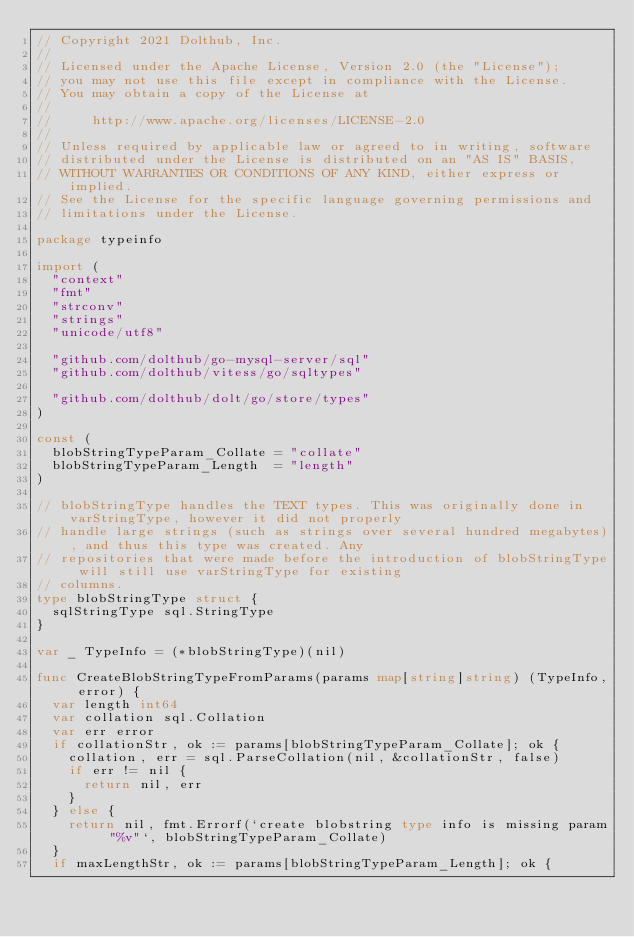<code> <loc_0><loc_0><loc_500><loc_500><_Go_>// Copyright 2021 Dolthub, Inc.
//
// Licensed under the Apache License, Version 2.0 (the "License");
// you may not use this file except in compliance with the License.
// You may obtain a copy of the License at
//
//     http://www.apache.org/licenses/LICENSE-2.0
//
// Unless required by applicable law or agreed to in writing, software
// distributed under the License is distributed on an "AS IS" BASIS,
// WITHOUT WARRANTIES OR CONDITIONS OF ANY KIND, either express or implied.
// See the License for the specific language governing permissions and
// limitations under the License.

package typeinfo

import (
	"context"
	"fmt"
	"strconv"
	"strings"
	"unicode/utf8"

	"github.com/dolthub/go-mysql-server/sql"
	"github.com/dolthub/vitess/go/sqltypes"

	"github.com/dolthub/dolt/go/store/types"
)

const (
	blobStringTypeParam_Collate = "collate"
	blobStringTypeParam_Length  = "length"
)

// blobStringType handles the TEXT types. This was originally done in varStringType, however it did not properly
// handle large strings (such as strings over several hundred megabytes), and thus this type was created. Any
// repositories that were made before the introduction of blobStringType will still use varStringType for existing
// columns.
type blobStringType struct {
	sqlStringType sql.StringType
}

var _ TypeInfo = (*blobStringType)(nil)

func CreateBlobStringTypeFromParams(params map[string]string) (TypeInfo, error) {
	var length int64
	var collation sql.Collation
	var err error
	if collationStr, ok := params[blobStringTypeParam_Collate]; ok {
		collation, err = sql.ParseCollation(nil, &collationStr, false)
		if err != nil {
			return nil, err
		}
	} else {
		return nil, fmt.Errorf(`create blobstring type info is missing param "%v"`, blobStringTypeParam_Collate)
	}
	if maxLengthStr, ok := params[blobStringTypeParam_Length]; ok {</code> 